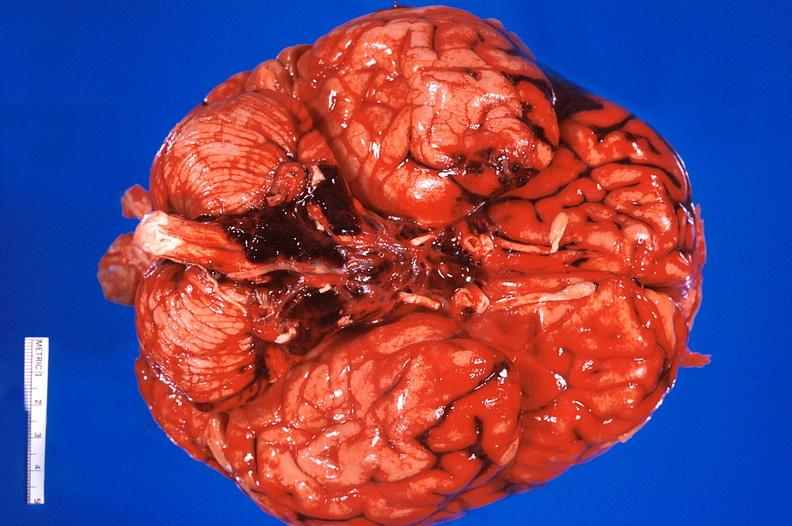what is present?
Answer the question using a single word or phrase. Nervous 